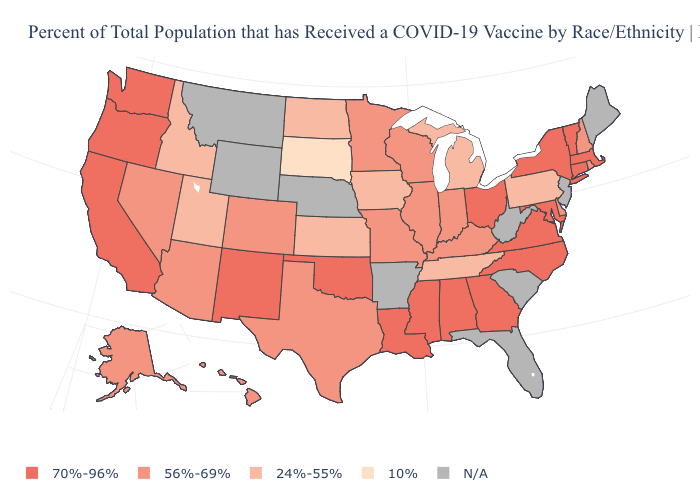Is the legend a continuous bar?
Be succinct. No. Name the states that have a value in the range 10%?
Answer briefly. South Dakota. What is the lowest value in the West?
Short answer required. 24%-55%. What is the value of California?
Quick response, please. 70%-96%. Does the first symbol in the legend represent the smallest category?
Give a very brief answer. No. Name the states that have a value in the range 56%-69%?
Short answer required. Alaska, Arizona, Colorado, Delaware, Hawaii, Illinois, Indiana, Kentucky, Minnesota, Missouri, Nevada, New Hampshire, Rhode Island, Texas, Wisconsin. What is the lowest value in states that border West Virginia?
Give a very brief answer. 24%-55%. Does Massachusetts have the highest value in the USA?
Give a very brief answer. Yes. Which states have the lowest value in the MidWest?
Keep it brief. South Dakota. Which states have the highest value in the USA?
Quick response, please. Alabama, California, Connecticut, Georgia, Louisiana, Maryland, Massachusetts, Mississippi, New Mexico, New York, North Carolina, Ohio, Oklahoma, Oregon, Vermont, Virginia, Washington. What is the value of Alaska?
Give a very brief answer. 56%-69%. What is the value of Utah?
Answer briefly. 24%-55%. Does South Dakota have the lowest value in the MidWest?
Write a very short answer. Yes. 